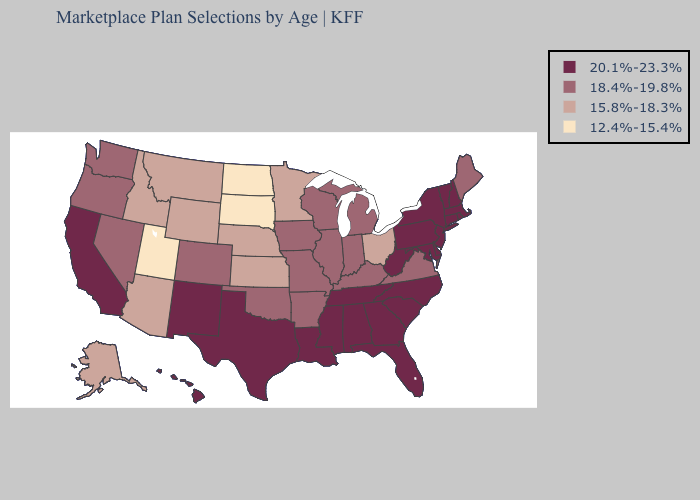Is the legend a continuous bar?
Give a very brief answer. No. Does Indiana have the same value as Hawaii?
Keep it brief. No. Which states have the lowest value in the USA?
Concise answer only. North Dakota, South Dakota, Utah. What is the value of Texas?
Short answer required. 20.1%-23.3%. Among the states that border Texas , does Louisiana have the highest value?
Quick response, please. Yes. Does New York have the lowest value in the USA?
Quick response, please. No. Does New Jersey have the highest value in the Northeast?
Answer briefly. Yes. What is the value of Delaware?
Write a very short answer. 20.1%-23.3%. Among the states that border Michigan , does Ohio have the highest value?
Give a very brief answer. No. Does Utah have the same value as North Dakota?
Concise answer only. Yes. Name the states that have a value in the range 15.8%-18.3%?
Give a very brief answer. Alaska, Arizona, Idaho, Kansas, Minnesota, Montana, Nebraska, Ohio, Wyoming. Which states hav the highest value in the South?
Be succinct. Alabama, Delaware, Florida, Georgia, Louisiana, Maryland, Mississippi, North Carolina, South Carolina, Tennessee, Texas, West Virginia. Which states have the highest value in the USA?
Answer briefly. Alabama, California, Connecticut, Delaware, Florida, Georgia, Hawaii, Louisiana, Maryland, Massachusetts, Mississippi, New Hampshire, New Jersey, New Mexico, New York, North Carolina, Pennsylvania, Rhode Island, South Carolina, Tennessee, Texas, Vermont, West Virginia. What is the highest value in the South ?
Quick response, please. 20.1%-23.3%. What is the highest value in the USA?
Quick response, please. 20.1%-23.3%. 